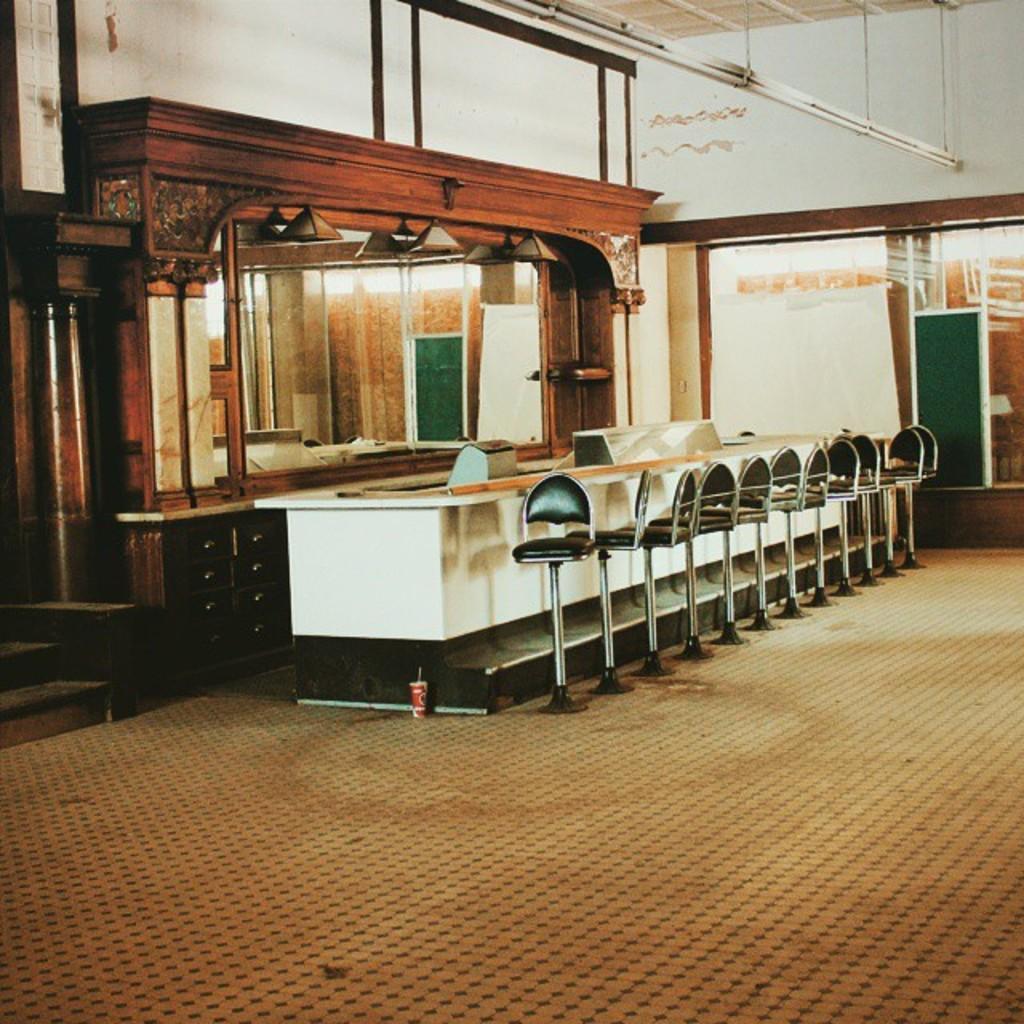How would you summarize this image in a sentence or two? There is one table and some chairs are arranged as we can see in the middle of this image. There is a mirror on the left side of this image. There is a wooden frame is attached to this mirror. There is a wall in the background. There is a carpet on the floor at the bottom of this image. 